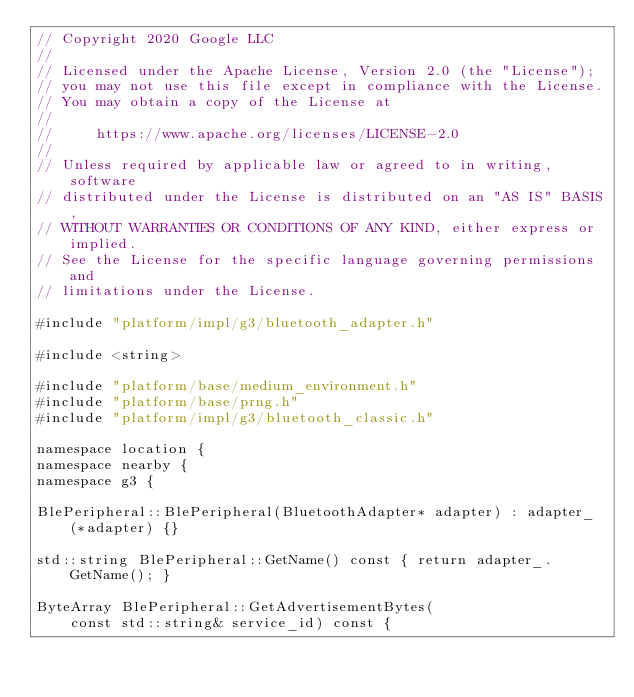<code> <loc_0><loc_0><loc_500><loc_500><_C++_>// Copyright 2020 Google LLC
//
// Licensed under the Apache License, Version 2.0 (the "License");
// you may not use this file except in compliance with the License.
// You may obtain a copy of the License at
//
//     https://www.apache.org/licenses/LICENSE-2.0
//
// Unless required by applicable law or agreed to in writing, software
// distributed under the License is distributed on an "AS IS" BASIS,
// WITHOUT WARRANTIES OR CONDITIONS OF ANY KIND, either express or implied.
// See the License for the specific language governing permissions and
// limitations under the License.

#include "platform/impl/g3/bluetooth_adapter.h"

#include <string>

#include "platform/base/medium_environment.h"
#include "platform/base/prng.h"
#include "platform/impl/g3/bluetooth_classic.h"

namespace location {
namespace nearby {
namespace g3 {

BlePeripheral::BlePeripheral(BluetoothAdapter* adapter) : adapter_(*adapter) {}

std::string BlePeripheral::GetName() const { return adapter_.GetName(); }

ByteArray BlePeripheral::GetAdvertisementBytes(
    const std::string& service_id) const {</code> 